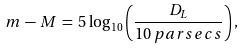<formula> <loc_0><loc_0><loc_500><loc_500>m \, - \, M \, = \, 5 \, \log _ { 1 0 } \left ( \frac { D _ { L } } { 1 0 \, p a r s e c s } \right ) ,</formula> 